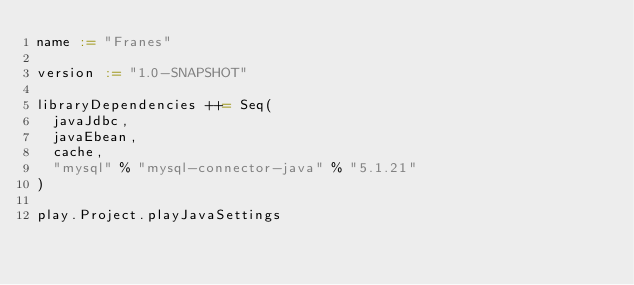<code> <loc_0><loc_0><loc_500><loc_500><_Scala_>name := "Franes"

version := "1.0-SNAPSHOT"

libraryDependencies ++= Seq(
  javaJdbc,
  javaEbean,
  cache,
  "mysql" % "mysql-connector-java" % "5.1.21"
)

play.Project.playJavaSettings
</code> 